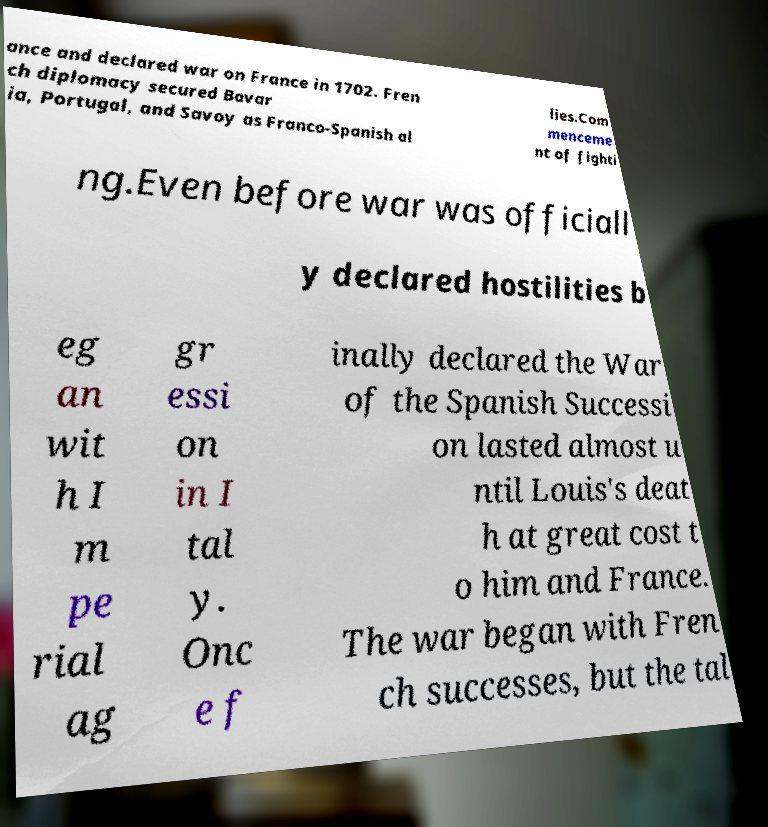For documentation purposes, I need the text within this image transcribed. Could you provide that? ance and declared war on France in 1702. Fren ch diplomacy secured Bavar ia, Portugal, and Savoy as Franco-Spanish al lies.Com menceme nt of fighti ng.Even before war was officiall y declared hostilities b eg an wit h I m pe rial ag gr essi on in I tal y. Onc e f inally declared the War of the Spanish Successi on lasted almost u ntil Louis's deat h at great cost t o him and France. The war began with Fren ch successes, but the tal 